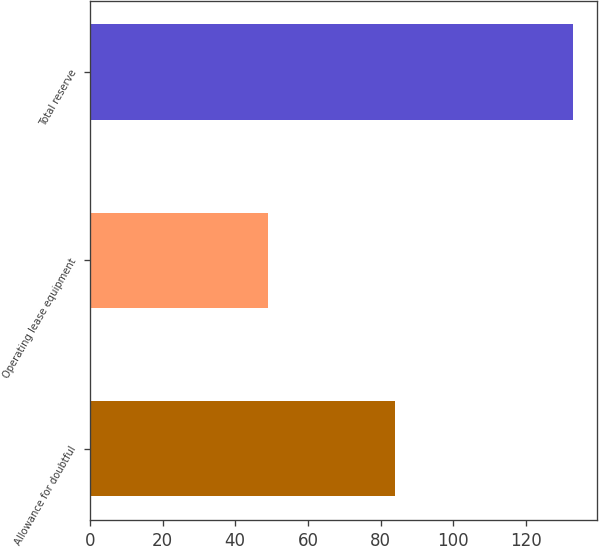<chart> <loc_0><loc_0><loc_500><loc_500><bar_chart><fcel>Allowance for doubtful<fcel>Operating lease equipment<fcel>Total reserve<nl><fcel>84<fcel>49<fcel>133<nl></chart> 